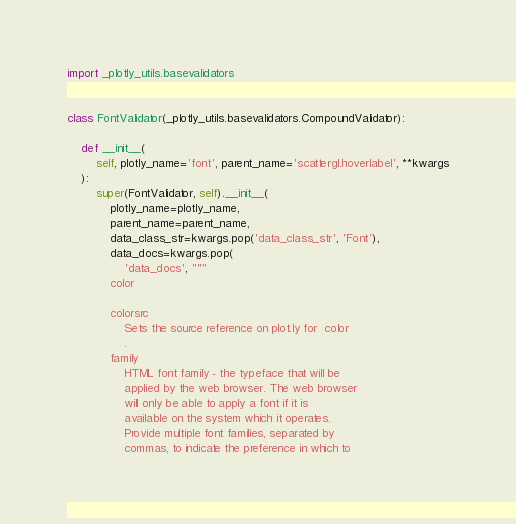<code> <loc_0><loc_0><loc_500><loc_500><_Python_>import _plotly_utils.basevalidators


class FontValidator(_plotly_utils.basevalidators.CompoundValidator):

    def __init__(
        self, plotly_name='font', parent_name='scattergl.hoverlabel', **kwargs
    ):
        super(FontValidator, self).__init__(
            plotly_name=plotly_name,
            parent_name=parent_name,
            data_class_str=kwargs.pop('data_class_str', 'Font'),
            data_docs=kwargs.pop(
                'data_docs', """
            color

            colorsrc
                Sets the source reference on plot.ly for  color
                .
            family
                HTML font family - the typeface that will be
                applied by the web browser. The web browser
                will only be able to apply a font if it is
                available on the system which it operates.
                Provide multiple font families, separated by
                commas, to indicate the preference in which to</code> 